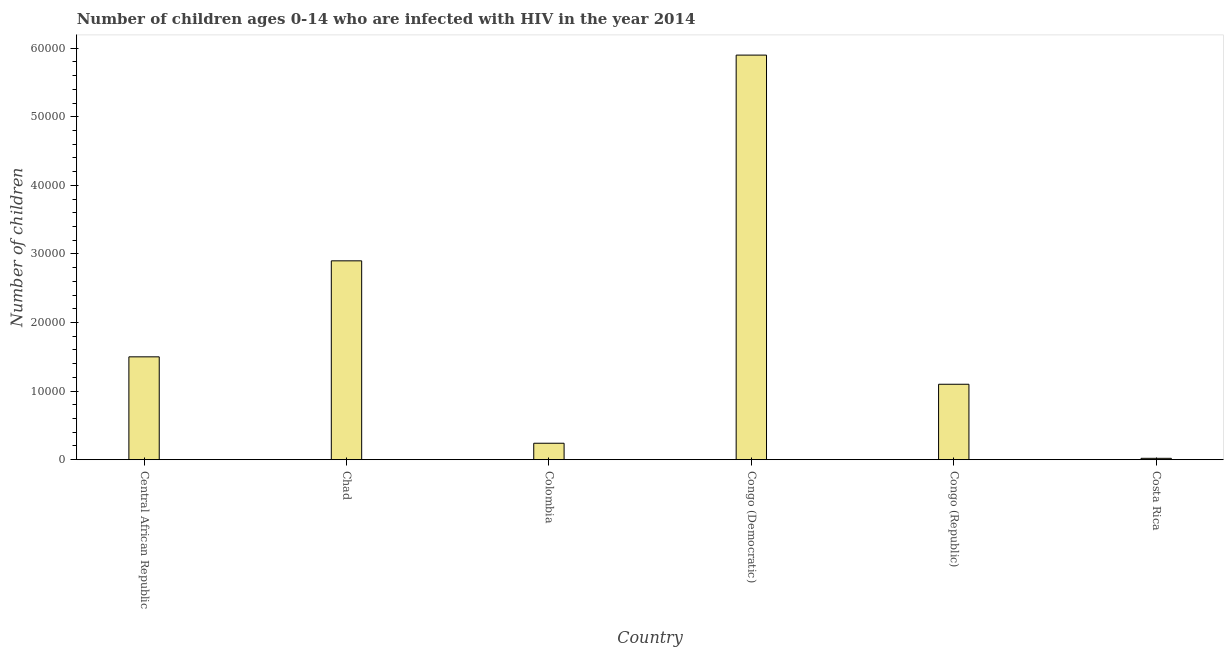Does the graph contain grids?
Keep it short and to the point. No. What is the title of the graph?
Provide a short and direct response. Number of children ages 0-14 who are infected with HIV in the year 2014. What is the label or title of the X-axis?
Your response must be concise. Country. What is the label or title of the Y-axis?
Your answer should be compact. Number of children. What is the number of children living with hiv in Colombia?
Offer a terse response. 2400. Across all countries, what is the maximum number of children living with hiv?
Your answer should be compact. 5.90e+04. Across all countries, what is the minimum number of children living with hiv?
Keep it short and to the point. 200. In which country was the number of children living with hiv maximum?
Ensure brevity in your answer.  Congo (Democratic). In which country was the number of children living with hiv minimum?
Provide a succinct answer. Costa Rica. What is the sum of the number of children living with hiv?
Give a very brief answer. 1.17e+05. What is the difference between the number of children living with hiv in Congo (Republic) and Costa Rica?
Offer a very short reply. 1.08e+04. What is the average number of children living with hiv per country?
Offer a terse response. 1.94e+04. What is the median number of children living with hiv?
Offer a very short reply. 1.30e+04. What is the ratio of the number of children living with hiv in Colombia to that in Congo (Democratic)?
Make the answer very short. 0.04. Is the difference between the number of children living with hiv in Congo (Democratic) and Costa Rica greater than the difference between any two countries?
Give a very brief answer. Yes. What is the difference between the highest and the second highest number of children living with hiv?
Make the answer very short. 3.00e+04. Is the sum of the number of children living with hiv in Congo (Democratic) and Congo (Republic) greater than the maximum number of children living with hiv across all countries?
Your answer should be compact. Yes. What is the difference between the highest and the lowest number of children living with hiv?
Provide a succinct answer. 5.88e+04. How many countries are there in the graph?
Provide a short and direct response. 6. What is the Number of children in Central African Republic?
Keep it short and to the point. 1.50e+04. What is the Number of children in Chad?
Keep it short and to the point. 2.90e+04. What is the Number of children of Colombia?
Your response must be concise. 2400. What is the Number of children of Congo (Democratic)?
Your answer should be very brief. 5.90e+04. What is the Number of children of Congo (Republic)?
Provide a succinct answer. 1.10e+04. What is the Number of children of Costa Rica?
Ensure brevity in your answer.  200. What is the difference between the Number of children in Central African Republic and Chad?
Provide a succinct answer. -1.40e+04. What is the difference between the Number of children in Central African Republic and Colombia?
Make the answer very short. 1.26e+04. What is the difference between the Number of children in Central African Republic and Congo (Democratic)?
Keep it short and to the point. -4.40e+04. What is the difference between the Number of children in Central African Republic and Congo (Republic)?
Your answer should be very brief. 4000. What is the difference between the Number of children in Central African Republic and Costa Rica?
Provide a succinct answer. 1.48e+04. What is the difference between the Number of children in Chad and Colombia?
Make the answer very short. 2.66e+04. What is the difference between the Number of children in Chad and Congo (Republic)?
Your answer should be compact. 1.80e+04. What is the difference between the Number of children in Chad and Costa Rica?
Your response must be concise. 2.88e+04. What is the difference between the Number of children in Colombia and Congo (Democratic)?
Make the answer very short. -5.66e+04. What is the difference between the Number of children in Colombia and Congo (Republic)?
Your response must be concise. -8600. What is the difference between the Number of children in Colombia and Costa Rica?
Offer a very short reply. 2200. What is the difference between the Number of children in Congo (Democratic) and Congo (Republic)?
Make the answer very short. 4.80e+04. What is the difference between the Number of children in Congo (Democratic) and Costa Rica?
Make the answer very short. 5.88e+04. What is the difference between the Number of children in Congo (Republic) and Costa Rica?
Provide a succinct answer. 1.08e+04. What is the ratio of the Number of children in Central African Republic to that in Chad?
Your answer should be very brief. 0.52. What is the ratio of the Number of children in Central African Republic to that in Colombia?
Give a very brief answer. 6.25. What is the ratio of the Number of children in Central African Republic to that in Congo (Democratic)?
Provide a short and direct response. 0.25. What is the ratio of the Number of children in Central African Republic to that in Congo (Republic)?
Ensure brevity in your answer.  1.36. What is the ratio of the Number of children in Chad to that in Colombia?
Provide a short and direct response. 12.08. What is the ratio of the Number of children in Chad to that in Congo (Democratic)?
Your response must be concise. 0.49. What is the ratio of the Number of children in Chad to that in Congo (Republic)?
Offer a very short reply. 2.64. What is the ratio of the Number of children in Chad to that in Costa Rica?
Your response must be concise. 145. What is the ratio of the Number of children in Colombia to that in Congo (Democratic)?
Your answer should be very brief. 0.04. What is the ratio of the Number of children in Colombia to that in Congo (Republic)?
Ensure brevity in your answer.  0.22. What is the ratio of the Number of children in Congo (Democratic) to that in Congo (Republic)?
Ensure brevity in your answer.  5.36. What is the ratio of the Number of children in Congo (Democratic) to that in Costa Rica?
Your response must be concise. 295. What is the ratio of the Number of children in Congo (Republic) to that in Costa Rica?
Your response must be concise. 55. 